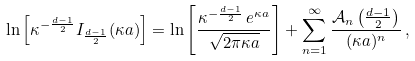Convert formula to latex. <formula><loc_0><loc_0><loc_500><loc_500>\ln \left [ \kappa ^ { - \frac { d - 1 } { 2 } } I _ { \frac { d - 1 } { 2 } } ( \kappa a ) \right ] = \ln \left [ \frac { \kappa ^ { - \frac { d - 1 } { 2 } } \, e ^ { \kappa a } } { \sqrt { 2 \pi \kappa a } } \right ] + \sum _ { n = 1 } ^ { \infty } \frac { \mathcal { A } _ { n } \left ( \frac { d - 1 } { 2 } \right ) } { ( \kappa a ) ^ { n } } \, ,</formula> 